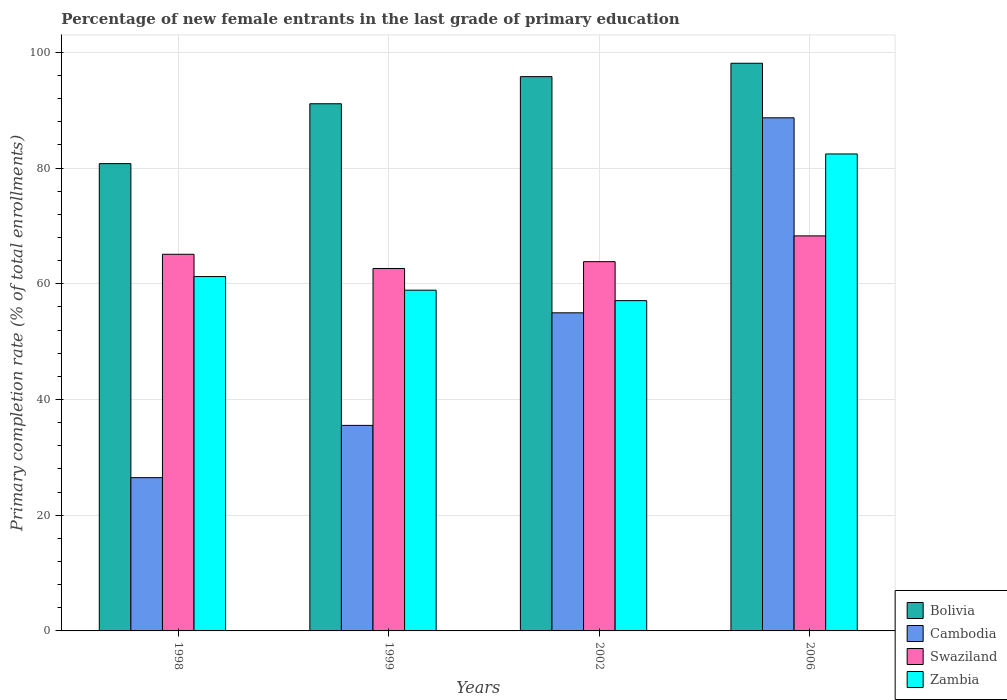How many different coloured bars are there?
Ensure brevity in your answer.  4. In how many cases, is the number of bars for a given year not equal to the number of legend labels?
Offer a very short reply. 0. What is the percentage of new female entrants in Swaziland in 1998?
Provide a short and direct response. 65.09. Across all years, what is the maximum percentage of new female entrants in Cambodia?
Offer a terse response. 88.68. Across all years, what is the minimum percentage of new female entrants in Cambodia?
Give a very brief answer. 26.49. What is the total percentage of new female entrants in Cambodia in the graph?
Give a very brief answer. 205.66. What is the difference between the percentage of new female entrants in Bolivia in 1998 and that in 2006?
Your response must be concise. -17.35. What is the difference between the percentage of new female entrants in Zambia in 2006 and the percentage of new female entrants in Swaziland in 2002?
Make the answer very short. 18.61. What is the average percentage of new female entrants in Zambia per year?
Provide a succinct answer. 64.91. In the year 2006, what is the difference between the percentage of new female entrants in Bolivia and percentage of new female entrants in Cambodia?
Make the answer very short. 9.43. What is the ratio of the percentage of new female entrants in Swaziland in 1999 to that in 2002?
Offer a very short reply. 0.98. Is the difference between the percentage of new female entrants in Bolivia in 1999 and 2006 greater than the difference between the percentage of new female entrants in Cambodia in 1999 and 2006?
Offer a very short reply. Yes. What is the difference between the highest and the second highest percentage of new female entrants in Zambia?
Keep it short and to the point. 21.19. What is the difference between the highest and the lowest percentage of new female entrants in Zambia?
Provide a short and direct response. 25.35. Is it the case that in every year, the sum of the percentage of new female entrants in Swaziland and percentage of new female entrants in Bolivia is greater than the sum of percentage of new female entrants in Cambodia and percentage of new female entrants in Zambia?
Keep it short and to the point. Yes. What does the 2nd bar from the left in 2006 represents?
Provide a succinct answer. Cambodia. What does the 2nd bar from the right in 1999 represents?
Give a very brief answer. Swaziland. Is it the case that in every year, the sum of the percentage of new female entrants in Zambia and percentage of new female entrants in Cambodia is greater than the percentage of new female entrants in Swaziland?
Make the answer very short. Yes. Are all the bars in the graph horizontal?
Your response must be concise. No. How many years are there in the graph?
Provide a succinct answer. 4. Does the graph contain any zero values?
Your answer should be compact. No. Does the graph contain grids?
Your answer should be compact. Yes. What is the title of the graph?
Offer a terse response. Percentage of new female entrants in the last grade of primary education. What is the label or title of the X-axis?
Provide a short and direct response. Years. What is the label or title of the Y-axis?
Ensure brevity in your answer.  Primary completion rate (% of total enrollments). What is the Primary completion rate (% of total enrollments) in Bolivia in 1998?
Provide a short and direct response. 80.76. What is the Primary completion rate (% of total enrollments) of Cambodia in 1998?
Provide a short and direct response. 26.49. What is the Primary completion rate (% of total enrollments) of Swaziland in 1998?
Ensure brevity in your answer.  65.09. What is the Primary completion rate (% of total enrollments) in Zambia in 1998?
Your answer should be compact. 61.24. What is the Primary completion rate (% of total enrollments) of Bolivia in 1999?
Offer a terse response. 91.1. What is the Primary completion rate (% of total enrollments) in Cambodia in 1999?
Your answer should be very brief. 35.52. What is the Primary completion rate (% of total enrollments) in Swaziland in 1999?
Make the answer very short. 62.63. What is the Primary completion rate (% of total enrollments) of Zambia in 1999?
Your answer should be compact. 58.89. What is the Primary completion rate (% of total enrollments) in Bolivia in 2002?
Your answer should be very brief. 95.79. What is the Primary completion rate (% of total enrollments) of Cambodia in 2002?
Your answer should be compact. 54.98. What is the Primary completion rate (% of total enrollments) in Swaziland in 2002?
Offer a very short reply. 63.81. What is the Primary completion rate (% of total enrollments) in Zambia in 2002?
Offer a terse response. 57.08. What is the Primary completion rate (% of total enrollments) in Bolivia in 2006?
Ensure brevity in your answer.  98.1. What is the Primary completion rate (% of total enrollments) of Cambodia in 2006?
Your answer should be very brief. 88.68. What is the Primary completion rate (% of total enrollments) of Swaziland in 2006?
Ensure brevity in your answer.  68.27. What is the Primary completion rate (% of total enrollments) of Zambia in 2006?
Provide a succinct answer. 82.43. Across all years, what is the maximum Primary completion rate (% of total enrollments) in Bolivia?
Provide a short and direct response. 98.1. Across all years, what is the maximum Primary completion rate (% of total enrollments) of Cambodia?
Your answer should be very brief. 88.68. Across all years, what is the maximum Primary completion rate (% of total enrollments) in Swaziland?
Your answer should be very brief. 68.27. Across all years, what is the maximum Primary completion rate (% of total enrollments) of Zambia?
Your answer should be very brief. 82.43. Across all years, what is the minimum Primary completion rate (% of total enrollments) of Bolivia?
Provide a short and direct response. 80.76. Across all years, what is the minimum Primary completion rate (% of total enrollments) of Cambodia?
Offer a terse response. 26.49. Across all years, what is the minimum Primary completion rate (% of total enrollments) of Swaziland?
Ensure brevity in your answer.  62.63. Across all years, what is the minimum Primary completion rate (% of total enrollments) of Zambia?
Provide a short and direct response. 57.08. What is the total Primary completion rate (% of total enrollments) of Bolivia in the graph?
Offer a very short reply. 365.75. What is the total Primary completion rate (% of total enrollments) of Cambodia in the graph?
Provide a succinct answer. 205.66. What is the total Primary completion rate (% of total enrollments) in Swaziland in the graph?
Provide a succinct answer. 259.81. What is the total Primary completion rate (% of total enrollments) of Zambia in the graph?
Your answer should be compact. 259.64. What is the difference between the Primary completion rate (% of total enrollments) in Bolivia in 1998 and that in 1999?
Keep it short and to the point. -10.35. What is the difference between the Primary completion rate (% of total enrollments) of Cambodia in 1998 and that in 1999?
Offer a very short reply. -9.03. What is the difference between the Primary completion rate (% of total enrollments) of Swaziland in 1998 and that in 1999?
Offer a terse response. 2.46. What is the difference between the Primary completion rate (% of total enrollments) of Zambia in 1998 and that in 1999?
Your response must be concise. 2.35. What is the difference between the Primary completion rate (% of total enrollments) of Bolivia in 1998 and that in 2002?
Offer a very short reply. -15.03. What is the difference between the Primary completion rate (% of total enrollments) of Cambodia in 1998 and that in 2002?
Ensure brevity in your answer.  -28.49. What is the difference between the Primary completion rate (% of total enrollments) in Swaziland in 1998 and that in 2002?
Your answer should be very brief. 1.28. What is the difference between the Primary completion rate (% of total enrollments) of Zambia in 1998 and that in 2002?
Your answer should be compact. 4.16. What is the difference between the Primary completion rate (% of total enrollments) in Bolivia in 1998 and that in 2006?
Your response must be concise. -17.35. What is the difference between the Primary completion rate (% of total enrollments) in Cambodia in 1998 and that in 2006?
Offer a very short reply. -62.19. What is the difference between the Primary completion rate (% of total enrollments) of Swaziland in 1998 and that in 2006?
Offer a very short reply. -3.18. What is the difference between the Primary completion rate (% of total enrollments) of Zambia in 1998 and that in 2006?
Provide a short and direct response. -21.19. What is the difference between the Primary completion rate (% of total enrollments) of Bolivia in 1999 and that in 2002?
Your answer should be compact. -4.69. What is the difference between the Primary completion rate (% of total enrollments) of Cambodia in 1999 and that in 2002?
Your answer should be very brief. -19.45. What is the difference between the Primary completion rate (% of total enrollments) in Swaziland in 1999 and that in 2002?
Your answer should be very brief. -1.18. What is the difference between the Primary completion rate (% of total enrollments) in Zambia in 1999 and that in 2002?
Your answer should be very brief. 1.81. What is the difference between the Primary completion rate (% of total enrollments) of Bolivia in 1999 and that in 2006?
Give a very brief answer. -7. What is the difference between the Primary completion rate (% of total enrollments) in Cambodia in 1999 and that in 2006?
Make the answer very short. -53.16. What is the difference between the Primary completion rate (% of total enrollments) of Swaziland in 1999 and that in 2006?
Keep it short and to the point. -5.64. What is the difference between the Primary completion rate (% of total enrollments) in Zambia in 1999 and that in 2006?
Give a very brief answer. -23.54. What is the difference between the Primary completion rate (% of total enrollments) in Bolivia in 2002 and that in 2006?
Your answer should be very brief. -2.31. What is the difference between the Primary completion rate (% of total enrollments) of Cambodia in 2002 and that in 2006?
Ensure brevity in your answer.  -33.7. What is the difference between the Primary completion rate (% of total enrollments) in Swaziland in 2002 and that in 2006?
Your answer should be very brief. -4.46. What is the difference between the Primary completion rate (% of total enrollments) of Zambia in 2002 and that in 2006?
Provide a succinct answer. -25.35. What is the difference between the Primary completion rate (% of total enrollments) of Bolivia in 1998 and the Primary completion rate (% of total enrollments) of Cambodia in 1999?
Your answer should be very brief. 45.24. What is the difference between the Primary completion rate (% of total enrollments) in Bolivia in 1998 and the Primary completion rate (% of total enrollments) in Swaziland in 1999?
Provide a succinct answer. 18.12. What is the difference between the Primary completion rate (% of total enrollments) of Bolivia in 1998 and the Primary completion rate (% of total enrollments) of Zambia in 1999?
Ensure brevity in your answer.  21.87. What is the difference between the Primary completion rate (% of total enrollments) in Cambodia in 1998 and the Primary completion rate (% of total enrollments) in Swaziland in 1999?
Your answer should be compact. -36.15. What is the difference between the Primary completion rate (% of total enrollments) in Cambodia in 1998 and the Primary completion rate (% of total enrollments) in Zambia in 1999?
Your answer should be compact. -32.4. What is the difference between the Primary completion rate (% of total enrollments) in Swaziland in 1998 and the Primary completion rate (% of total enrollments) in Zambia in 1999?
Give a very brief answer. 6.2. What is the difference between the Primary completion rate (% of total enrollments) in Bolivia in 1998 and the Primary completion rate (% of total enrollments) in Cambodia in 2002?
Provide a short and direct response. 25.78. What is the difference between the Primary completion rate (% of total enrollments) of Bolivia in 1998 and the Primary completion rate (% of total enrollments) of Swaziland in 2002?
Provide a succinct answer. 16.94. What is the difference between the Primary completion rate (% of total enrollments) of Bolivia in 1998 and the Primary completion rate (% of total enrollments) of Zambia in 2002?
Give a very brief answer. 23.68. What is the difference between the Primary completion rate (% of total enrollments) in Cambodia in 1998 and the Primary completion rate (% of total enrollments) in Swaziland in 2002?
Offer a very short reply. -37.33. What is the difference between the Primary completion rate (% of total enrollments) of Cambodia in 1998 and the Primary completion rate (% of total enrollments) of Zambia in 2002?
Your answer should be compact. -30.59. What is the difference between the Primary completion rate (% of total enrollments) in Swaziland in 1998 and the Primary completion rate (% of total enrollments) in Zambia in 2002?
Your answer should be very brief. 8.01. What is the difference between the Primary completion rate (% of total enrollments) in Bolivia in 1998 and the Primary completion rate (% of total enrollments) in Cambodia in 2006?
Provide a short and direct response. -7.92. What is the difference between the Primary completion rate (% of total enrollments) of Bolivia in 1998 and the Primary completion rate (% of total enrollments) of Swaziland in 2006?
Your response must be concise. 12.49. What is the difference between the Primary completion rate (% of total enrollments) of Bolivia in 1998 and the Primary completion rate (% of total enrollments) of Zambia in 2006?
Ensure brevity in your answer.  -1.67. What is the difference between the Primary completion rate (% of total enrollments) of Cambodia in 1998 and the Primary completion rate (% of total enrollments) of Swaziland in 2006?
Offer a very short reply. -41.78. What is the difference between the Primary completion rate (% of total enrollments) in Cambodia in 1998 and the Primary completion rate (% of total enrollments) in Zambia in 2006?
Your answer should be very brief. -55.94. What is the difference between the Primary completion rate (% of total enrollments) in Swaziland in 1998 and the Primary completion rate (% of total enrollments) in Zambia in 2006?
Your answer should be compact. -17.34. What is the difference between the Primary completion rate (% of total enrollments) of Bolivia in 1999 and the Primary completion rate (% of total enrollments) of Cambodia in 2002?
Make the answer very short. 36.13. What is the difference between the Primary completion rate (% of total enrollments) of Bolivia in 1999 and the Primary completion rate (% of total enrollments) of Swaziland in 2002?
Make the answer very short. 27.29. What is the difference between the Primary completion rate (% of total enrollments) of Bolivia in 1999 and the Primary completion rate (% of total enrollments) of Zambia in 2002?
Your response must be concise. 34.02. What is the difference between the Primary completion rate (% of total enrollments) in Cambodia in 1999 and the Primary completion rate (% of total enrollments) in Swaziland in 2002?
Keep it short and to the point. -28.29. What is the difference between the Primary completion rate (% of total enrollments) of Cambodia in 1999 and the Primary completion rate (% of total enrollments) of Zambia in 2002?
Offer a terse response. -21.56. What is the difference between the Primary completion rate (% of total enrollments) in Swaziland in 1999 and the Primary completion rate (% of total enrollments) in Zambia in 2002?
Your answer should be very brief. 5.55. What is the difference between the Primary completion rate (% of total enrollments) of Bolivia in 1999 and the Primary completion rate (% of total enrollments) of Cambodia in 2006?
Give a very brief answer. 2.43. What is the difference between the Primary completion rate (% of total enrollments) of Bolivia in 1999 and the Primary completion rate (% of total enrollments) of Swaziland in 2006?
Your answer should be compact. 22.83. What is the difference between the Primary completion rate (% of total enrollments) in Bolivia in 1999 and the Primary completion rate (% of total enrollments) in Zambia in 2006?
Ensure brevity in your answer.  8.68. What is the difference between the Primary completion rate (% of total enrollments) in Cambodia in 1999 and the Primary completion rate (% of total enrollments) in Swaziland in 2006?
Keep it short and to the point. -32.75. What is the difference between the Primary completion rate (% of total enrollments) in Cambodia in 1999 and the Primary completion rate (% of total enrollments) in Zambia in 2006?
Your answer should be compact. -46.91. What is the difference between the Primary completion rate (% of total enrollments) in Swaziland in 1999 and the Primary completion rate (% of total enrollments) in Zambia in 2006?
Provide a short and direct response. -19.79. What is the difference between the Primary completion rate (% of total enrollments) in Bolivia in 2002 and the Primary completion rate (% of total enrollments) in Cambodia in 2006?
Offer a terse response. 7.11. What is the difference between the Primary completion rate (% of total enrollments) of Bolivia in 2002 and the Primary completion rate (% of total enrollments) of Swaziland in 2006?
Ensure brevity in your answer.  27.52. What is the difference between the Primary completion rate (% of total enrollments) of Bolivia in 2002 and the Primary completion rate (% of total enrollments) of Zambia in 2006?
Offer a terse response. 13.36. What is the difference between the Primary completion rate (% of total enrollments) of Cambodia in 2002 and the Primary completion rate (% of total enrollments) of Swaziland in 2006?
Offer a terse response. -13.29. What is the difference between the Primary completion rate (% of total enrollments) of Cambodia in 2002 and the Primary completion rate (% of total enrollments) of Zambia in 2006?
Provide a short and direct response. -27.45. What is the difference between the Primary completion rate (% of total enrollments) of Swaziland in 2002 and the Primary completion rate (% of total enrollments) of Zambia in 2006?
Provide a short and direct response. -18.61. What is the average Primary completion rate (% of total enrollments) of Bolivia per year?
Your answer should be compact. 91.44. What is the average Primary completion rate (% of total enrollments) in Cambodia per year?
Provide a succinct answer. 51.42. What is the average Primary completion rate (% of total enrollments) of Swaziland per year?
Provide a succinct answer. 64.95. What is the average Primary completion rate (% of total enrollments) of Zambia per year?
Your answer should be very brief. 64.91. In the year 1998, what is the difference between the Primary completion rate (% of total enrollments) in Bolivia and Primary completion rate (% of total enrollments) in Cambodia?
Ensure brevity in your answer.  54.27. In the year 1998, what is the difference between the Primary completion rate (% of total enrollments) in Bolivia and Primary completion rate (% of total enrollments) in Swaziland?
Ensure brevity in your answer.  15.66. In the year 1998, what is the difference between the Primary completion rate (% of total enrollments) of Bolivia and Primary completion rate (% of total enrollments) of Zambia?
Your answer should be compact. 19.52. In the year 1998, what is the difference between the Primary completion rate (% of total enrollments) in Cambodia and Primary completion rate (% of total enrollments) in Swaziland?
Make the answer very short. -38.6. In the year 1998, what is the difference between the Primary completion rate (% of total enrollments) in Cambodia and Primary completion rate (% of total enrollments) in Zambia?
Provide a succinct answer. -34.75. In the year 1998, what is the difference between the Primary completion rate (% of total enrollments) in Swaziland and Primary completion rate (% of total enrollments) in Zambia?
Ensure brevity in your answer.  3.85. In the year 1999, what is the difference between the Primary completion rate (% of total enrollments) of Bolivia and Primary completion rate (% of total enrollments) of Cambodia?
Give a very brief answer. 55.58. In the year 1999, what is the difference between the Primary completion rate (% of total enrollments) in Bolivia and Primary completion rate (% of total enrollments) in Swaziland?
Ensure brevity in your answer.  28.47. In the year 1999, what is the difference between the Primary completion rate (% of total enrollments) of Bolivia and Primary completion rate (% of total enrollments) of Zambia?
Make the answer very short. 32.22. In the year 1999, what is the difference between the Primary completion rate (% of total enrollments) in Cambodia and Primary completion rate (% of total enrollments) in Swaziland?
Give a very brief answer. -27.11. In the year 1999, what is the difference between the Primary completion rate (% of total enrollments) of Cambodia and Primary completion rate (% of total enrollments) of Zambia?
Give a very brief answer. -23.37. In the year 1999, what is the difference between the Primary completion rate (% of total enrollments) in Swaziland and Primary completion rate (% of total enrollments) in Zambia?
Ensure brevity in your answer.  3.75. In the year 2002, what is the difference between the Primary completion rate (% of total enrollments) of Bolivia and Primary completion rate (% of total enrollments) of Cambodia?
Keep it short and to the point. 40.81. In the year 2002, what is the difference between the Primary completion rate (% of total enrollments) of Bolivia and Primary completion rate (% of total enrollments) of Swaziland?
Offer a very short reply. 31.98. In the year 2002, what is the difference between the Primary completion rate (% of total enrollments) in Bolivia and Primary completion rate (% of total enrollments) in Zambia?
Your answer should be very brief. 38.71. In the year 2002, what is the difference between the Primary completion rate (% of total enrollments) in Cambodia and Primary completion rate (% of total enrollments) in Swaziland?
Provide a succinct answer. -8.84. In the year 2002, what is the difference between the Primary completion rate (% of total enrollments) in Cambodia and Primary completion rate (% of total enrollments) in Zambia?
Keep it short and to the point. -2.11. In the year 2002, what is the difference between the Primary completion rate (% of total enrollments) in Swaziland and Primary completion rate (% of total enrollments) in Zambia?
Offer a terse response. 6.73. In the year 2006, what is the difference between the Primary completion rate (% of total enrollments) of Bolivia and Primary completion rate (% of total enrollments) of Cambodia?
Offer a very short reply. 9.43. In the year 2006, what is the difference between the Primary completion rate (% of total enrollments) in Bolivia and Primary completion rate (% of total enrollments) in Swaziland?
Your answer should be very brief. 29.83. In the year 2006, what is the difference between the Primary completion rate (% of total enrollments) in Bolivia and Primary completion rate (% of total enrollments) in Zambia?
Your answer should be compact. 15.67. In the year 2006, what is the difference between the Primary completion rate (% of total enrollments) of Cambodia and Primary completion rate (% of total enrollments) of Swaziland?
Make the answer very short. 20.41. In the year 2006, what is the difference between the Primary completion rate (% of total enrollments) of Cambodia and Primary completion rate (% of total enrollments) of Zambia?
Your answer should be compact. 6.25. In the year 2006, what is the difference between the Primary completion rate (% of total enrollments) of Swaziland and Primary completion rate (% of total enrollments) of Zambia?
Give a very brief answer. -14.16. What is the ratio of the Primary completion rate (% of total enrollments) of Bolivia in 1998 to that in 1999?
Your response must be concise. 0.89. What is the ratio of the Primary completion rate (% of total enrollments) of Cambodia in 1998 to that in 1999?
Keep it short and to the point. 0.75. What is the ratio of the Primary completion rate (% of total enrollments) of Swaziland in 1998 to that in 1999?
Provide a succinct answer. 1.04. What is the ratio of the Primary completion rate (% of total enrollments) of Bolivia in 1998 to that in 2002?
Provide a succinct answer. 0.84. What is the ratio of the Primary completion rate (% of total enrollments) of Cambodia in 1998 to that in 2002?
Provide a succinct answer. 0.48. What is the ratio of the Primary completion rate (% of total enrollments) of Swaziland in 1998 to that in 2002?
Provide a succinct answer. 1.02. What is the ratio of the Primary completion rate (% of total enrollments) of Zambia in 1998 to that in 2002?
Ensure brevity in your answer.  1.07. What is the ratio of the Primary completion rate (% of total enrollments) of Bolivia in 1998 to that in 2006?
Offer a very short reply. 0.82. What is the ratio of the Primary completion rate (% of total enrollments) in Cambodia in 1998 to that in 2006?
Offer a terse response. 0.3. What is the ratio of the Primary completion rate (% of total enrollments) in Swaziland in 1998 to that in 2006?
Your response must be concise. 0.95. What is the ratio of the Primary completion rate (% of total enrollments) of Zambia in 1998 to that in 2006?
Your answer should be compact. 0.74. What is the ratio of the Primary completion rate (% of total enrollments) of Bolivia in 1999 to that in 2002?
Your answer should be compact. 0.95. What is the ratio of the Primary completion rate (% of total enrollments) in Cambodia in 1999 to that in 2002?
Make the answer very short. 0.65. What is the ratio of the Primary completion rate (% of total enrollments) of Swaziland in 1999 to that in 2002?
Your answer should be compact. 0.98. What is the ratio of the Primary completion rate (% of total enrollments) of Zambia in 1999 to that in 2002?
Give a very brief answer. 1.03. What is the ratio of the Primary completion rate (% of total enrollments) of Bolivia in 1999 to that in 2006?
Your answer should be compact. 0.93. What is the ratio of the Primary completion rate (% of total enrollments) of Cambodia in 1999 to that in 2006?
Ensure brevity in your answer.  0.4. What is the ratio of the Primary completion rate (% of total enrollments) of Swaziland in 1999 to that in 2006?
Provide a short and direct response. 0.92. What is the ratio of the Primary completion rate (% of total enrollments) in Zambia in 1999 to that in 2006?
Offer a terse response. 0.71. What is the ratio of the Primary completion rate (% of total enrollments) of Bolivia in 2002 to that in 2006?
Ensure brevity in your answer.  0.98. What is the ratio of the Primary completion rate (% of total enrollments) of Cambodia in 2002 to that in 2006?
Provide a succinct answer. 0.62. What is the ratio of the Primary completion rate (% of total enrollments) of Swaziland in 2002 to that in 2006?
Make the answer very short. 0.93. What is the ratio of the Primary completion rate (% of total enrollments) of Zambia in 2002 to that in 2006?
Give a very brief answer. 0.69. What is the difference between the highest and the second highest Primary completion rate (% of total enrollments) in Bolivia?
Give a very brief answer. 2.31. What is the difference between the highest and the second highest Primary completion rate (% of total enrollments) in Cambodia?
Your response must be concise. 33.7. What is the difference between the highest and the second highest Primary completion rate (% of total enrollments) of Swaziland?
Provide a succinct answer. 3.18. What is the difference between the highest and the second highest Primary completion rate (% of total enrollments) of Zambia?
Your response must be concise. 21.19. What is the difference between the highest and the lowest Primary completion rate (% of total enrollments) in Bolivia?
Provide a succinct answer. 17.35. What is the difference between the highest and the lowest Primary completion rate (% of total enrollments) of Cambodia?
Ensure brevity in your answer.  62.19. What is the difference between the highest and the lowest Primary completion rate (% of total enrollments) in Swaziland?
Keep it short and to the point. 5.64. What is the difference between the highest and the lowest Primary completion rate (% of total enrollments) in Zambia?
Keep it short and to the point. 25.35. 